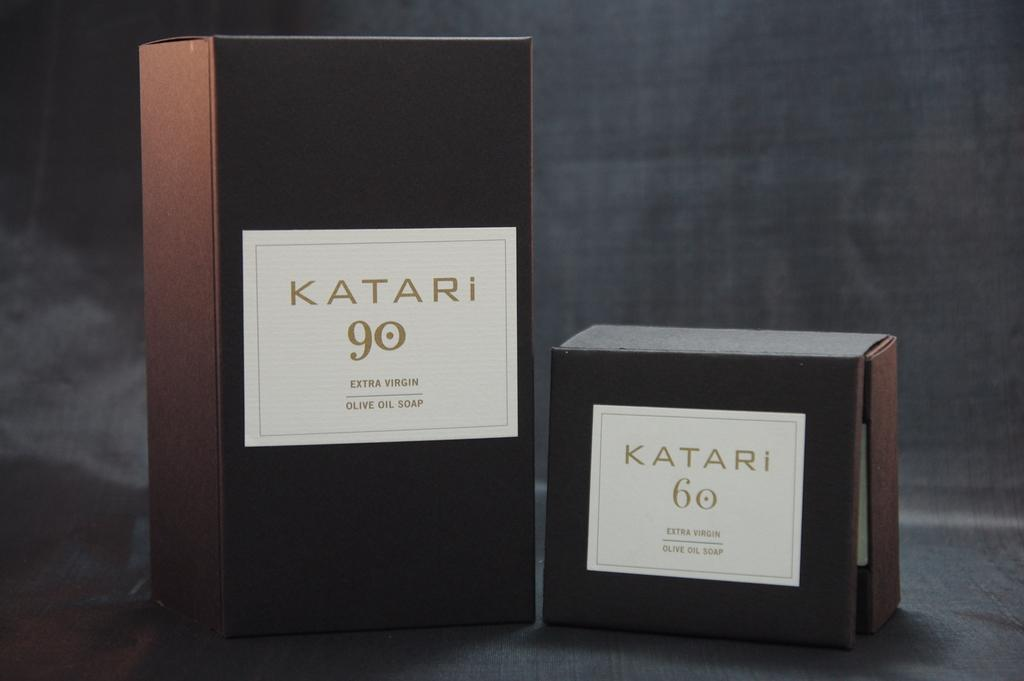<image>
Describe the image concisely. Katari 60 box next to a larger Katari 60 box. 